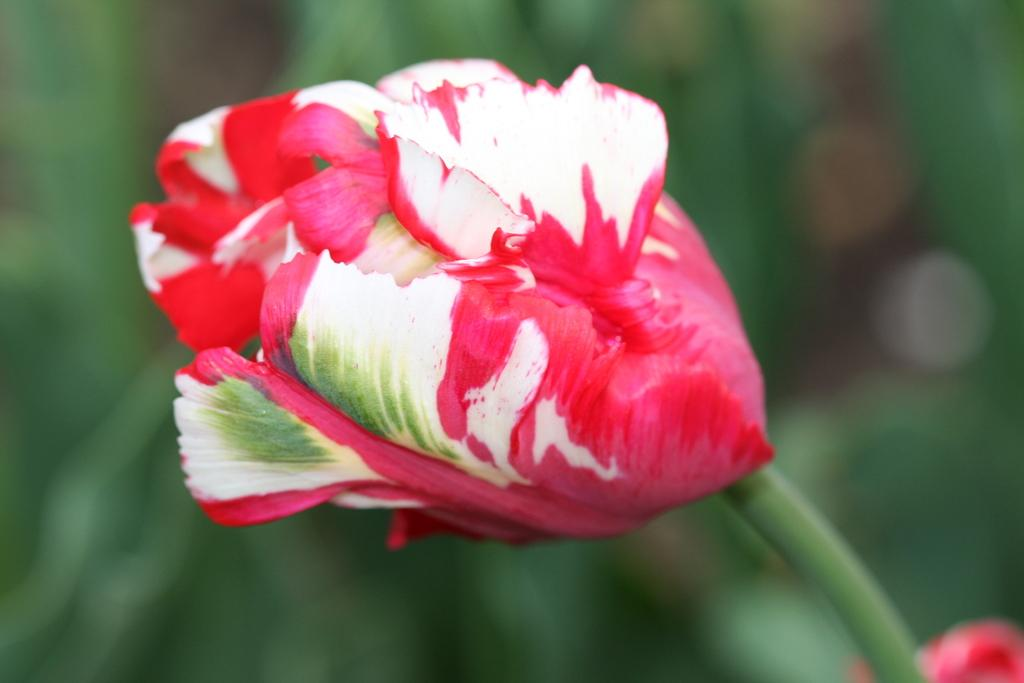What is the main subject of the image? There is a flower with a stem in the image. Are there any other flowers visible in the image? Yes, there is another flower at the bottom of the image. Can you describe the background of the image? The background of the image is blurred. What story does the mother tell about the eggs in the image? There are no eggs or mother present in the image, so it is not possible to answer that question. 